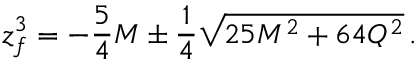Convert formula to latex. <formula><loc_0><loc_0><loc_500><loc_500>z _ { f } ^ { 3 } = - { \frac { 5 } { 4 } } M \pm { \frac { 1 } { 4 } } \sqrt { 2 5 M ^ { 2 } + 6 4 Q ^ { 2 } } \, .</formula> 